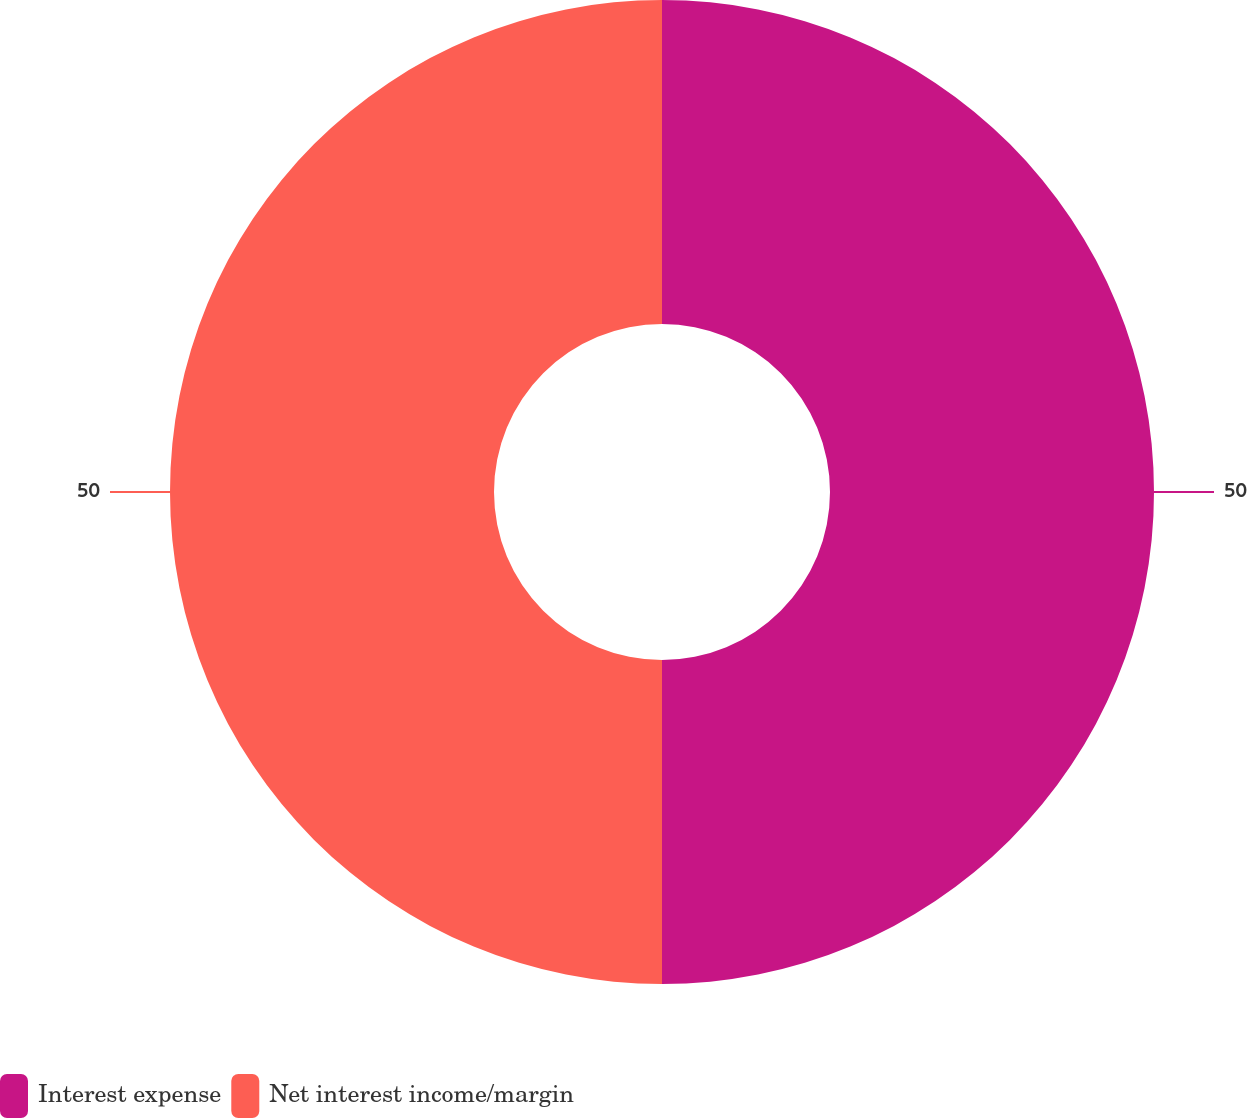<chart> <loc_0><loc_0><loc_500><loc_500><pie_chart><fcel>Interest expense<fcel>Net interest income/margin<nl><fcel>50.0%<fcel>50.0%<nl></chart> 